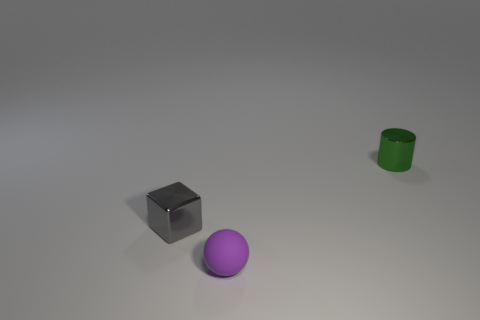Add 1 small rubber spheres. How many objects exist? 4 Subtract 1 balls. How many balls are left? 0 Subtract 0 gray spheres. How many objects are left? 3 Subtract all spheres. How many objects are left? 2 Subtract all green blocks. Subtract all purple balls. How many blocks are left? 1 Subtract all yellow cylinders. How many blue cubes are left? 0 Subtract all cyan metallic objects. Subtract all purple balls. How many objects are left? 2 Add 1 green things. How many green things are left? 2 Add 3 green metal cylinders. How many green metal cylinders exist? 4 